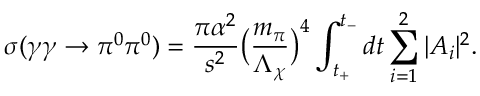Convert formula to latex. <formula><loc_0><loc_0><loc_500><loc_500>\sigma ( \gamma \gamma \to \pi ^ { 0 } \pi ^ { 0 } ) = { \frac { \pi \alpha ^ { 2 } } { s ^ { 2 } } } \left ( { \frac { m _ { \pi } } { \Lambda _ { \chi } } } \right ) ^ { 4 } \int _ { t _ { + } } ^ { t _ { - } } d t \sum _ { i = 1 } ^ { 2 } | A _ { i } | ^ { 2 } .</formula> 